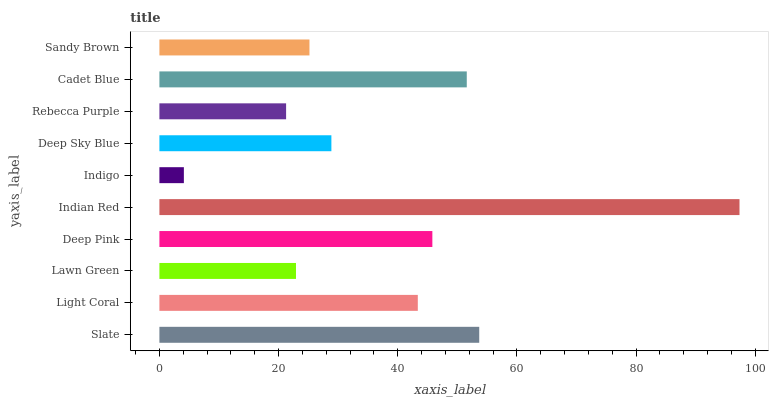Is Indigo the minimum?
Answer yes or no. Yes. Is Indian Red the maximum?
Answer yes or no. Yes. Is Light Coral the minimum?
Answer yes or no. No. Is Light Coral the maximum?
Answer yes or no. No. Is Slate greater than Light Coral?
Answer yes or no. Yes. Is Light Coral less than Slate?
Answer yes or no. Yes. Is Light Coral greater than Slate?
Answer yes or no. No. Is Slate less than Light Coral?
Answer yes or no. No. Is Light Coral the high median?
Answer yes or no. Yes. Is Deep Sky Blue the low median?
Answer yes or no. Yes. Is Lawn Green the high median?
Answer yes or no. No. Is Indian Red the low median?
Answer yes or no. No. 